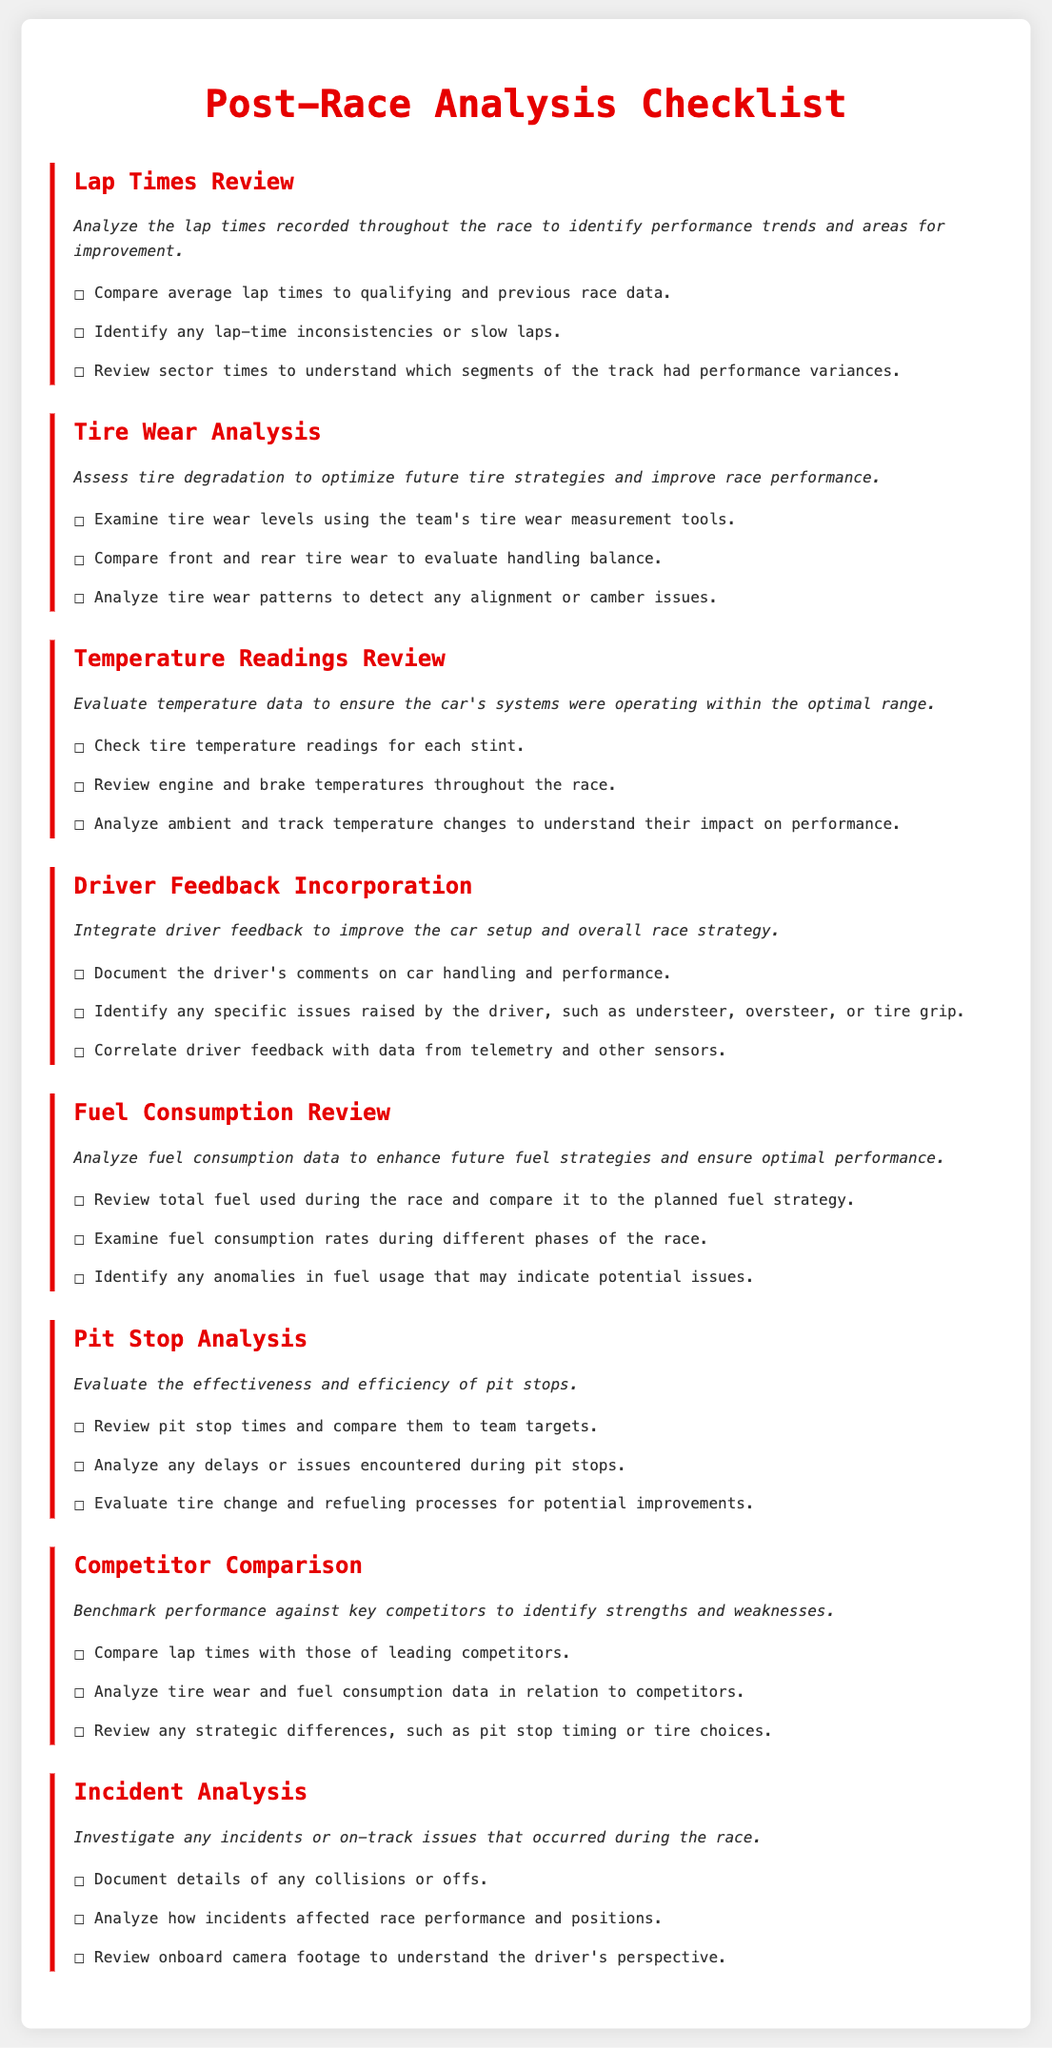What is the first item in the checklist? The first item in the checklist is "Lap Times Review."
Answer: Lap Times Review How many checklist items are there in total? The checklist contains a total of eight items.
Answer: Eight What is the main purpose of the Tire Wear Analysis section? The main purpose of the Tire Wear Analysis section is to assess tire degradation to optimize future tire strategies and improve race performance.
Answer: Assess tire degradation What specific aspect of temperature readings is reviewed? The specific aspect reviewed includes engine and brake temperatures throughout the race.
Answer: Engine and brake temperatures What type of feedback is integrated in the Driver Feedback Incorporation section? Driver feedback on car handling and performance is integrated in this section.
Answer: Car handling and performance How does the Pit Stop Analysis section suggest measuring effectiveness? The section suggests reviewing pit stop times and comparing them to team targets.
Answer: Review pit stop times What should be analyzed in the Incident Analysis section? The details of any collisions or offs should be analyzed in this section.
Answer: Collisions or offs What do you compare in the Competitor Comparison section? In the Competitor Comparison section, lap times with those of leading competitors are compared.
Answer: Lap times What is the goal of reviewing fuel consumption data? The goal is to enhance future fuel strategies and ensure optimal performance.
Answer: Enhance fuel strategies 